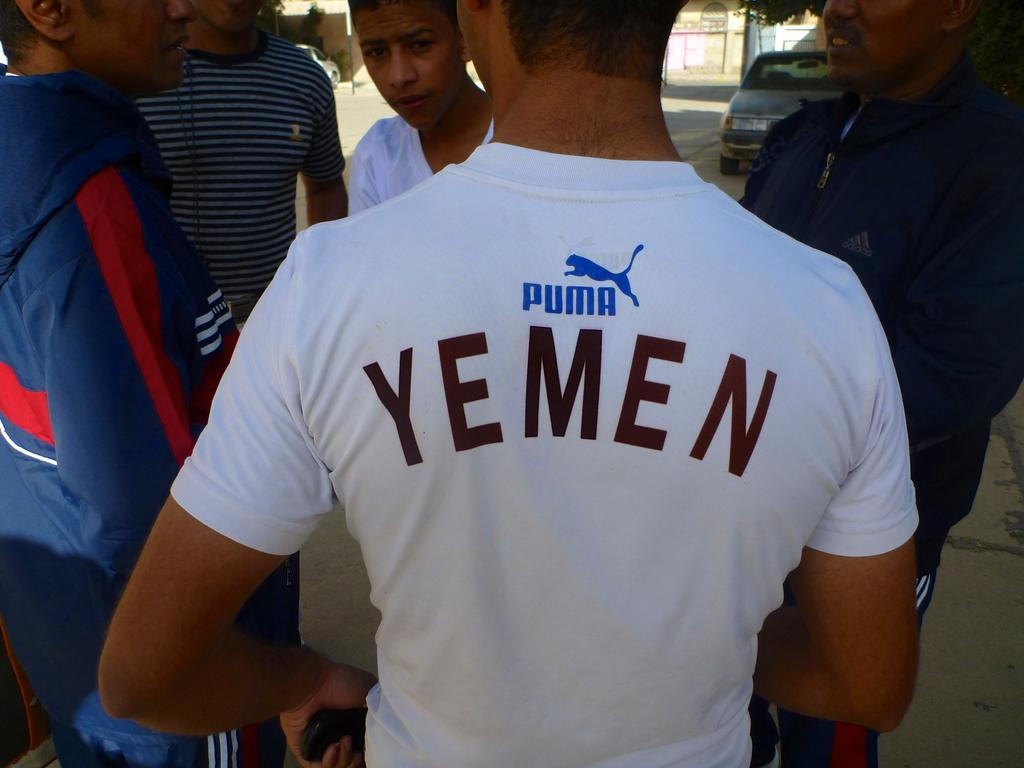<image>
Provide a brief description of the given image. The guy in the white shirt has a Puma shirt on. 